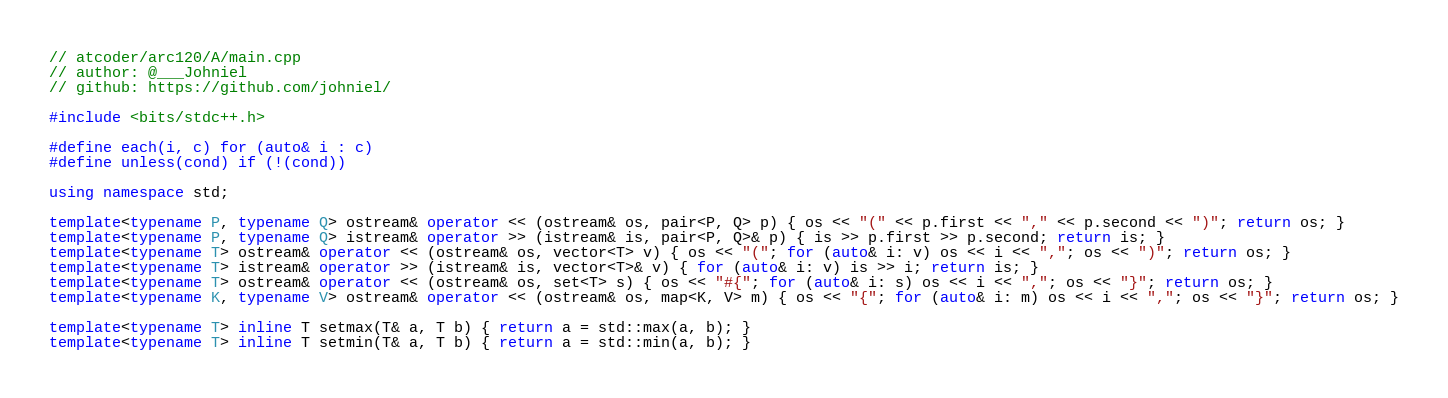Convert code to text. <code><loc_0><loc_0><loc_500><loc_500><_C++_>// atcoder/arc120/A/main.cpp
// author: @___Johniel
// github: https://github.com/johniel/

#include <bits/stdc++.h>

#define each(i, c) for (auto& i : c)
#define unless(cond) if (!(cond))

using namespace std;

template<typename P, typename Q> ostream& operator << (ostream& os, pair<P, Q> p) { os << "(" << p.first << "," << p.second << ")"; return os; }
template<typename P, typename Q> istream& operator >> (istream& is, pair<P, Q>& p) { is >> p.first >> p.second; return is; }
template<typename T> ostream& operator << (ostream& os, vector<T> v) { os << "("; for (auto& i: v) os << i << ","; os << ")"; return os; }
template<typename T> istream& operator >> (istream& is, vector<T>& v) { for (auto& i: v) is >> i; return is; }
template<typename T> ostream& operator << (ostream& os, set<T> s) { os << "#{"; for (auto& i: s) os << i << ","; os << "}"; return os; }
template<typename K, typename V> ostream& operator << (ostream& os, map<K, V> m) { os << "{"; for (auto& i: m) os << i << ","; os << "}"; return os; }

template<typename T> inline T setmax(T& a, T b) { return a = std::max(a, b); }
template<typename T> inline T setmin(T& a, T b) { return a = std::min(a, b); }
</code> 